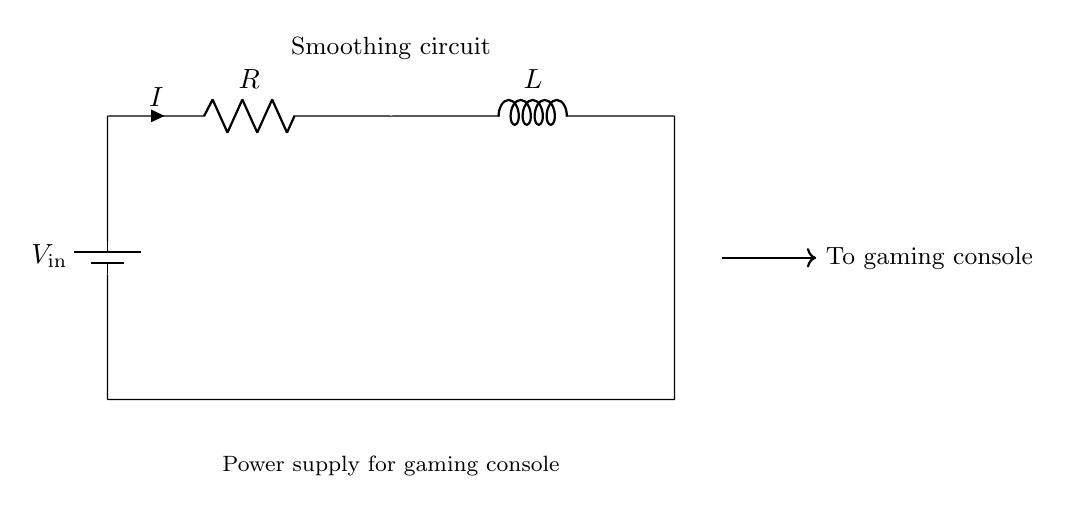What does the battery represent in this circuit? The battery represents the voltage source, providing electrical energy to the circuit. In this diagram, it is labeled as V_in.
Answer: V_in What component is labeled with the letter R? The component labeled with the letter R is the resistor. Resistors are used to limit current and drop voltage in a circuit.
Answer: Resistor What does the component L do in this circuit? The component L represents the inductor, which stores energy in a magnetic field when current passes through it. This helps smooth voltage fluctuations.
Answer: Inductor How does the inductor help the gaming console? The inductor helps by storing energy and releasing it slowly, which smooths out voltage fluctuations that can affect the performance of the gaming console. This results in more stable power supply.
Answer: Smoothing voltage What happens to current I when the voltage fluctuations occur? When voltage fluctuations happen, the inductor resists sudden changes in current due to its property of self-inductance, which helps maintain a steady flow of current in the circuit.
Answer: Steady flow What type of circuit is illustrated here? The circuit illustrated here is a simple RL circuit consisting of a resistor and an inductor in series, often used for filtering or smoothing applications.
Answer: RL circuit 